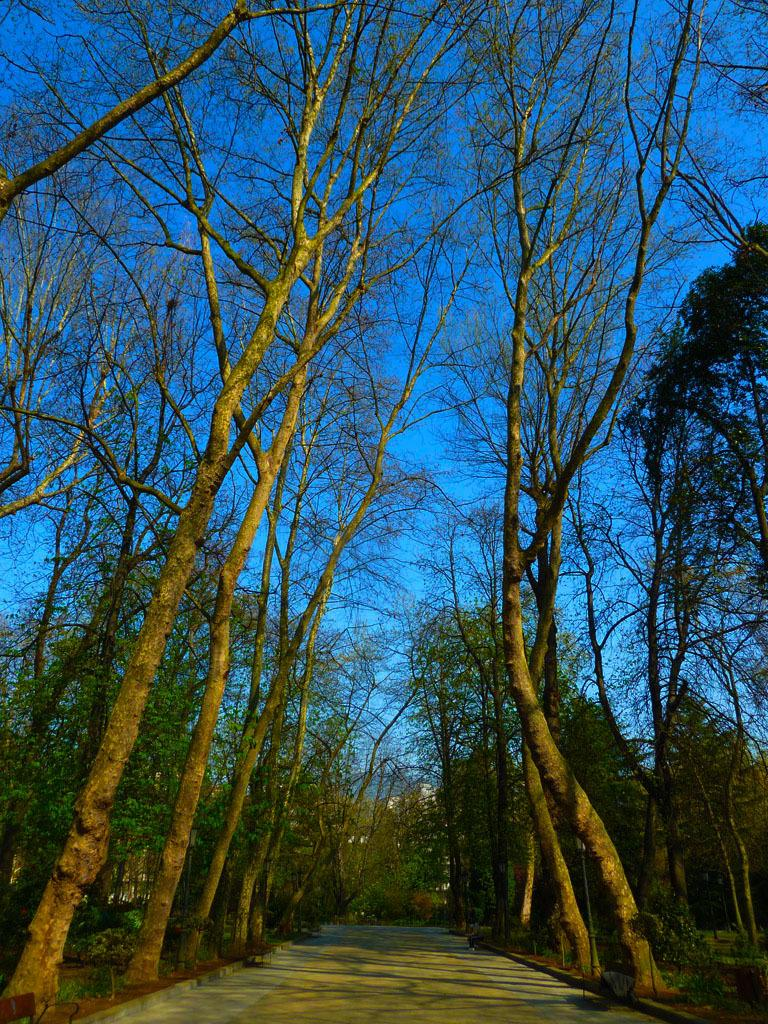What is the main feature in the middle of the image? There is a path in the middle of the image. What can be seen on both sides of the path? There are trees on both sides of the path. What type of eggnog can be seen in the image? There is no eggnog present in the image. What is the effect of the trees on the path in the image? The provided facts do not mention any specific effect of the trees on the path, so we cannot answer this question. 